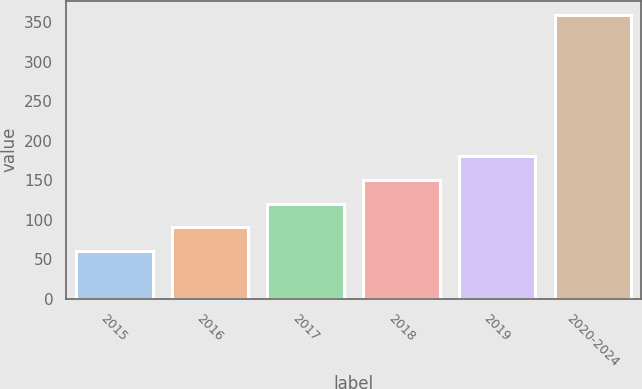Convert chart. <chart><loc_0><loc_0><loc_500><loc_500><bar_chart><fcel>2015<fcel>2016<fcel>2017<fcel>2018<fcel>2019<fcel>2020-2024<nl><fcel>60.3<fcel>90.23<fcel>120.16<fcel>150.09<fcel>180.02<fcel>359.6<nl></chart> 